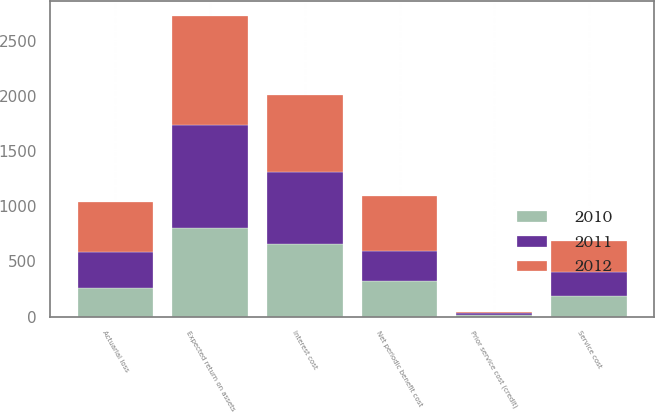<chart> <loc_0><loc_0><loc_500><loc_500><stacked_bar_chart><ecel><fcel>Service cost<fcel>Interest cost<fcel>Expected return on assets<fcel>Prior service cost (credit)<fcel>Actuarial loss<fcel>Net periodic benefit cost<nl><fcel>2012<fcel>280<fcel>698<fcel>988<fcel>15<fcel>450<fcel>500<nl><fcel>2011<fcel>212<fcel>649<fcel>939<fcel>14<fcel>331<fcel>267<nl><fcel>2010<fcel>190<fcel>660<fcel>799<fcel>14<fcel>254<fcel>324<nl></chart> 